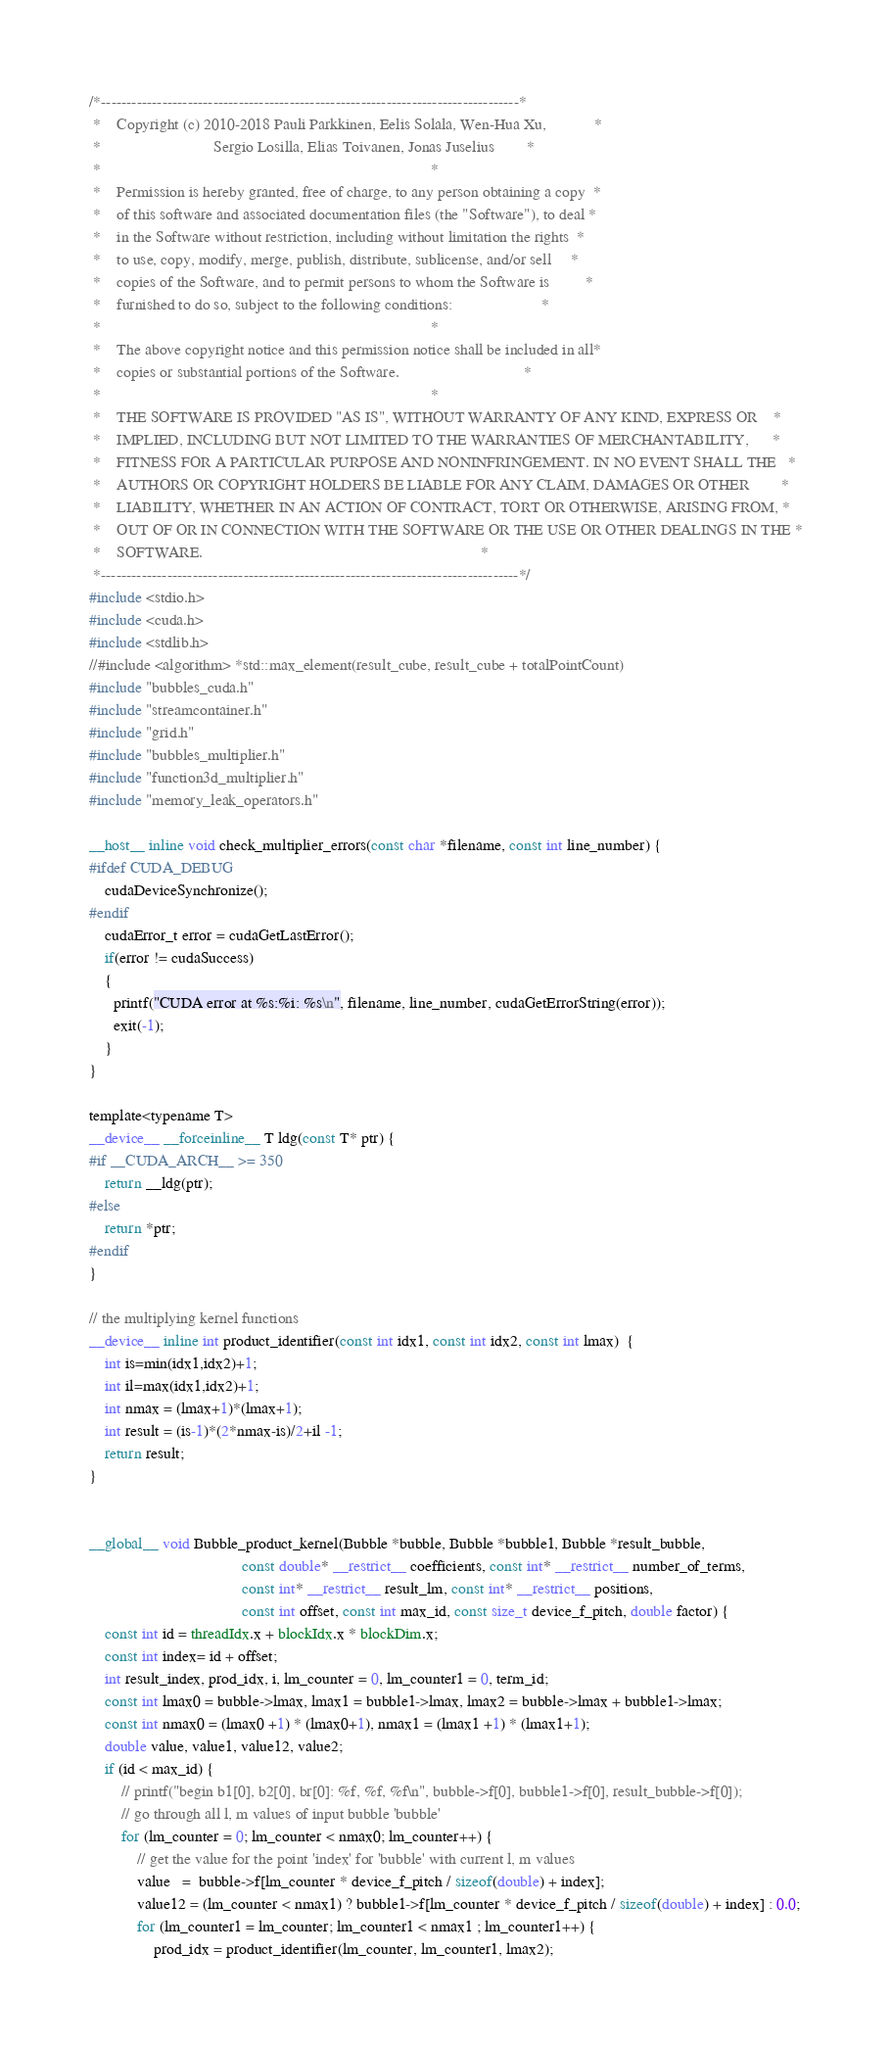<code> <loc_0><loc_0><loc_500><loc_500><_Cuda_>/*----------------------------------------------------------------------------------*
 *    Copyright (c) 2010-2018 Pauli Parkkinen, Eelis Solala, Wen-Hua Xu,            *
 *                            Sergio Losilla, Elias Toivanen, Jonas Juselius        *
 *                                                                                  *
 *    Permission is hereby granted, free of charge, to any person obtaining a copy  *
 *    of this software and associated documentation files (the "Software"), to deal *
 *    in the Software without restriction, including without limitation the rights  *
 *    to use, copy, modify, merge, publish, distribute, sublicense, and/or sell     *
 *    copies of the Software, and to permit persons to whom the Software is         *
 *    furnished to do so, subject to the following conditions:                      *
 *                                                                                  *
 *    The above copyright notice and this permission notice shall be included in all*
 *    copies or substantial portions of the Software.                               *
 *                                                                                  *
 *    THE SOFTWARE IS PROVIDED "AS IS", WITHOUT WARRANTY OF ANY KIND, EXPRESS OR    *
 *    IMPLIED, INCLUDING BUT NOT LIMITED TO THE WARRANTIES OF MERCHANTABILITY,      *
 *    FITNESS FOR A PARTICULAR PURPOSE AND NONINFRINGEMENT. IN NO EVENT SHALL THE   *
 *    AUTHORS OR COPYRIGHT HOLDERS BE LIABLE FOR ANY CLAIM, DAMAGES OR OTHER        *
 *    LIABILITY, WHETHER IN AN ACTION OF CONTRACT, TORT OR OTHERWISE, ARISING FROM, *
 *    OUT OF OR IN CONNECTION WITH THE SOFTWARE OR THE USE OR OTHER DEALINGS IN THE *
 *    SOFTWARE.                                                                     *
 *----------------------------------------------------------------------------------*/
#include <stdio.h>
#include <cuda.h>
#include <stdlib.h>
//#include <algorithm> *std::max_element(result_cube, result_cube + totalPointCount)
#include "bubbles_cuda.h"
#include "streamcontainer.h"
#include "grid.h"
#include "bubbles_multiplier.h"
#include "function3d_multiplier.h"
#include "memory_leak_operators.h"

__host__ inline void check_multiplier_errors(const char *filename, const int line_number) {
#ifdef CUDA_DEBUG
    cudaDeviceSynchronize();
#endif
    cudaError_t error = cudaGetLastError();
    if(error != cudaSuccess)
    {
      printf("CUDA error at %s:%i: %s\n", filename, line_number, cudaGetErrorString(error));
      exit(-1);
    }
}

template<typename T>
__device__ __forceinline__ T ldg(const T* ptr) {
#if __CUDA_ARCH__ >= 350
    return __ldg(ptr);
#else
    return *ptr;
#endif
}

// the multiplying kernel functions
__device__ inline int product_identifier(const int idx1, const int idx2, const int lmax)  {
    int is=min(idx1,idx2)+1;
    int il=max(idx1,idx2)+1;
    int nmax = (lmax+1)*(lmax+1);
    int result = (is-1)*(2*nmax-is)/2+il -1;
    return result;
}


__global__ void Bubble_product_kernel(Bubble *bubble, Bubble *bubble1, Bubble *result_bubble, 
                                      const double* __restrict__ coefficients, const int* __restrict__ number_of_terms,
                                      const int* __restrict__ result_lm, const int* __restrict__ positions,
                                      const int offset, const int max_id, const size_t device_f_pitch, double factor) {
    const int id = threadIdx.x + blockIdx.x * blockDim.x;
    const int index= id + offset;
    int result_index, prod_idx, i, lm_counter = 0, lm_counter1 = 0, term_id;
    const int lmax0 = bubble->lmax, lmax1 = bubble1->lmax, lmax2 = bubble->lmax + bubble1->lmax;
    const int nmax0 = (lmax0 +1) * (lmax0+1), nmax1 = (lmax1 +1) * (lmax1+1);
    double value, value1, value12, value2;
    if (id < max_id) {
        // printf("begin b1[0], b2[0], br[0]: %f, %f, %f\n", bubble->f[0], bubble1->f[0], result_bubble->f[0]);
        // go through all l, m values of input bubble 'bubble'
        for (lm_counter = 0; lm_counter < nmax0; lm_counter++) {
            // get the value for the point 'index' for 'bubble' with current l, m values
            value   =  bubble->f[lm_counter * device_f_pitch / sizeof(double) + index];
            value12 = (lm_counter < nmax1) ? bubble1->f[lm_counter * device_f_pitch / sizeof(double) + index] : 0.0;
            for (lm_counter1 = lm_counter; lm_counter1 < nmax1 ; lm_counter1++) {
                prod_idx = product_identifier(lm_counter, lm_counter1, lmax2);</code> 